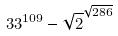Convert formula to latex. <formula><loc_0><loc_0><loc_500><loc_500>3 3 ^ { 1 0 9 } - \sqrt { 2 } ^ { \sqrt { 2 8 6 } }</formula> 